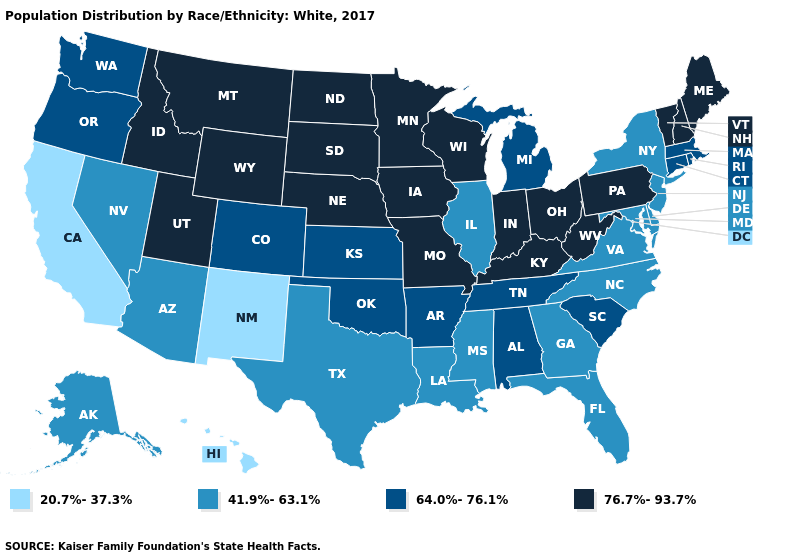What is the value of Idaho?
Give a very brief answer. 76.7%-93.7%. What is the lowest value in the Northeast?
Give a very brief answer. 41.9%-63.1%. Which states have the lowest value in the MidWest?
Answer briefly. Illinois. What is the value of Missouri?
Quick response, please. 76.7%-93.7%. Among the states that border Oregon , which have the lowest value?
Be succinct. California. Does the first symbol in the legend represent the smallest category?
Keep it brief. Yes. What is the lowest value in the USA?
Answer briefly. 20.7%-37.3%. Is the legend a continuous bar?
Write a very short answer. No. What is the value of Pennsylvania?
Short answer required. 76.7%-93.7%. What is the value of Indiana?
Keep it brief. 76.7%-93.7%. Among the states that border North Dakota , which have the lowest value?
Write a very short answer. Minnesota, Montana, South Dakota. Does Pennsylvania have a higher value than South Dakota?
Quick response, please. No. What is the value of New Jersey?
Short answer required. 41.9%-63.1%. What is the lowest value in the West?
Concise answer only. 20.7%-37.3%. Which states have the lowest value in the Northeast?
Give a very brief answer. New Jersey, New York. 